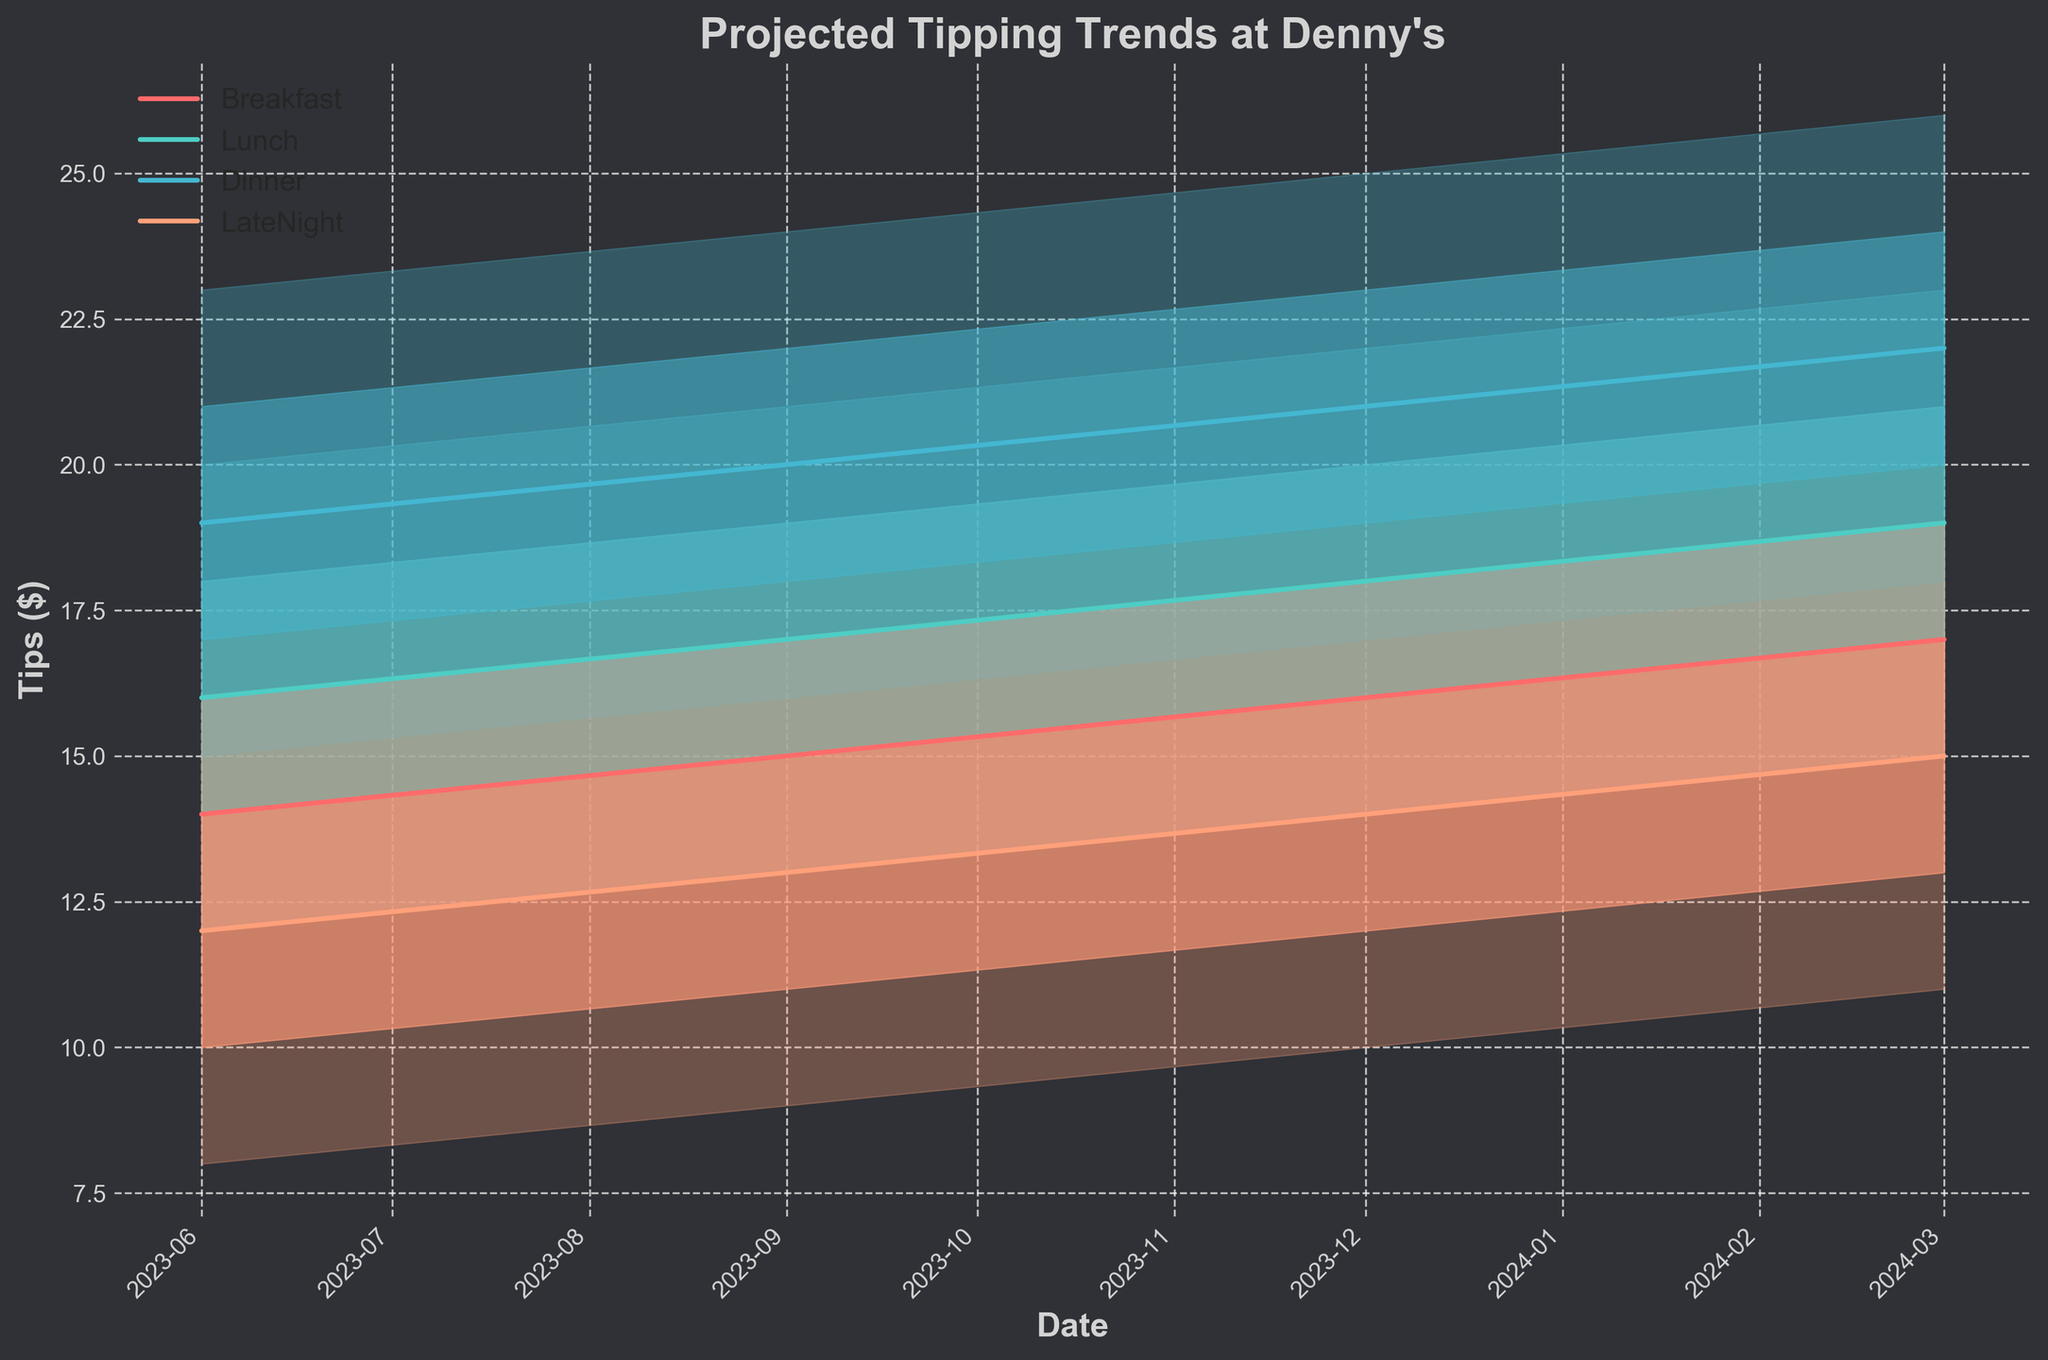What is the title of the figure? The title is typically found at the top of the chart, displaying the overall subject or focus of the figure.
Answer: Projected Tipping Trends at Denny's How many different meal times are represented in the figure? The figure uses color-coded lines and fills to represent different meal times. Count the distinct meal times in the legend.
Answer: Four What is the highest projected tip for Dinner in December 2023? The highest value for the "High" projection in December 2023 for Dinner can be observed directly from the figure.
Answer: 25 dollars Which meal time shows the highest median projected tip in March 2024? Look at the “Mid” value for each meal time in March 2024; the meal time with the highest midline represents the highest median projection.
Answer: Dinner What are the colors used for each meal time? The figure’s legend shows which color corresponds to each meal time, differentiating them in the chart.
Answer: Breakfast (red), Lunch (cyan), Dinner (blue), LateNight (orange) Which meal time shows the greatest increase in projected mid-level tips from June 2023 to March 2024? Find the difference between the mid values for June 2023 and March 2024 for each meal time, and then determine which is the greatest.
Answer: Dinner How do the projected tips for Breakfast in September 2023 compare to December 2023? Compare the low, low-mid, mid, high-mid, and high values for Breakfast between September and December 2023.
Answer: The projected tips for Breakfast in December 2023 are higher than in September 2023 What is the trend for projected tips for Late Night from June 2023 to March 2024? Observe the direction and changes in the mid values for Late Night across the dates from June 2023 to March 2024.
Answer: The trend is upward; tips are increasing over time Which meal time exhibits the widest range (difference between high and low) in projected tips in March 2024? Calculate the difference between the high and low projections for each meal time in March 2024 and identify the largest gap.
Answer: Dinner 